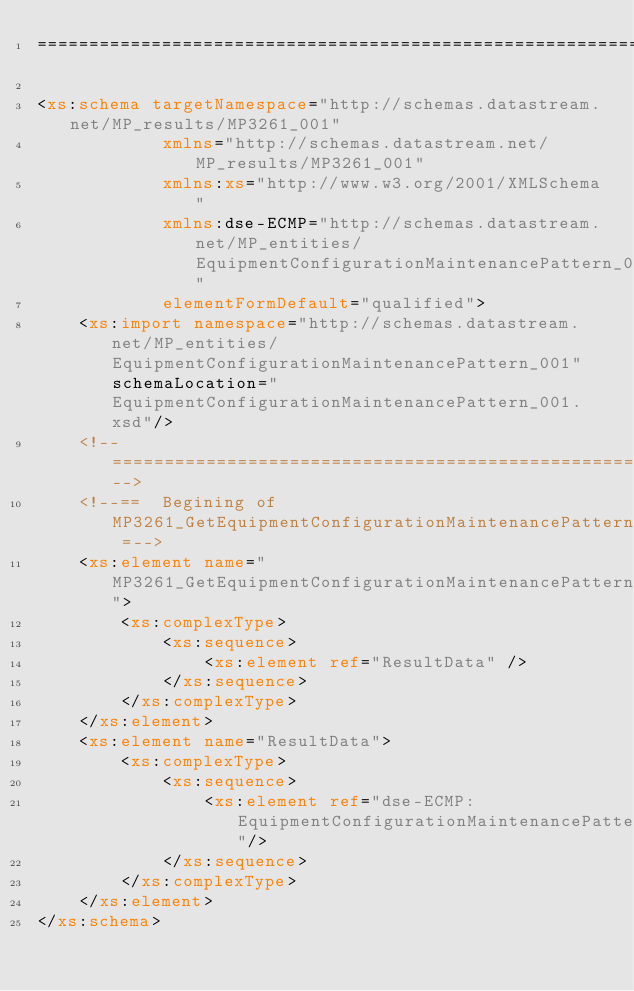Convert code to text. <code><loc_0><loc_0><loc_500><loc_500><_XML_>==================================================================================-->  

<xs:schema targetNamespace="http://schemas.datastream.net/MP_results/MP3261_001" 
			xmlns="http://schemas.datastream.net/MP_results/MP3261_001" 
			xmlns:xs="http://www.w3.org/2001/XMLSchema" 
			xmlns:dse-ECMP="http://schemas.datastream.net/MP_entities/EquipmentConfigurationMaintenancePattern_001"			
			elementFormDefault="qualified">
	<xs:import namespace="http://schemas.datastream.net/MP_entities/EquipmentConfigurationMaintenancePattern_001" schemaLocation="EquipmentConfigurationMaintenancePattern_001.xsd"/>
	<!--===============================================================================-->
	<!--==  Begining of MP3261_GetEquipmentConfigurationMaintenancePattern_001_Result =-->
	<xs:element name="MP3261_GetEquipmentConfigurationMaintenancePattern_001_Result">
		<xs:complexType>
			<xs:sequence>
				<xs:element ref="ResultData" />
			</xs:sequence>
		</xs:complexType>
	</xs:element>
	<xs:element name="ResultData">
		<xs:complexType>
			<xs:sequence>
				<xs:element ref="dse-ECMP:EquipmentConfigurationMaintenancePattern"/>
			</xs:sequence>
		</xs:complexType>
	</xs:element>
</xs:schema>
</code> 